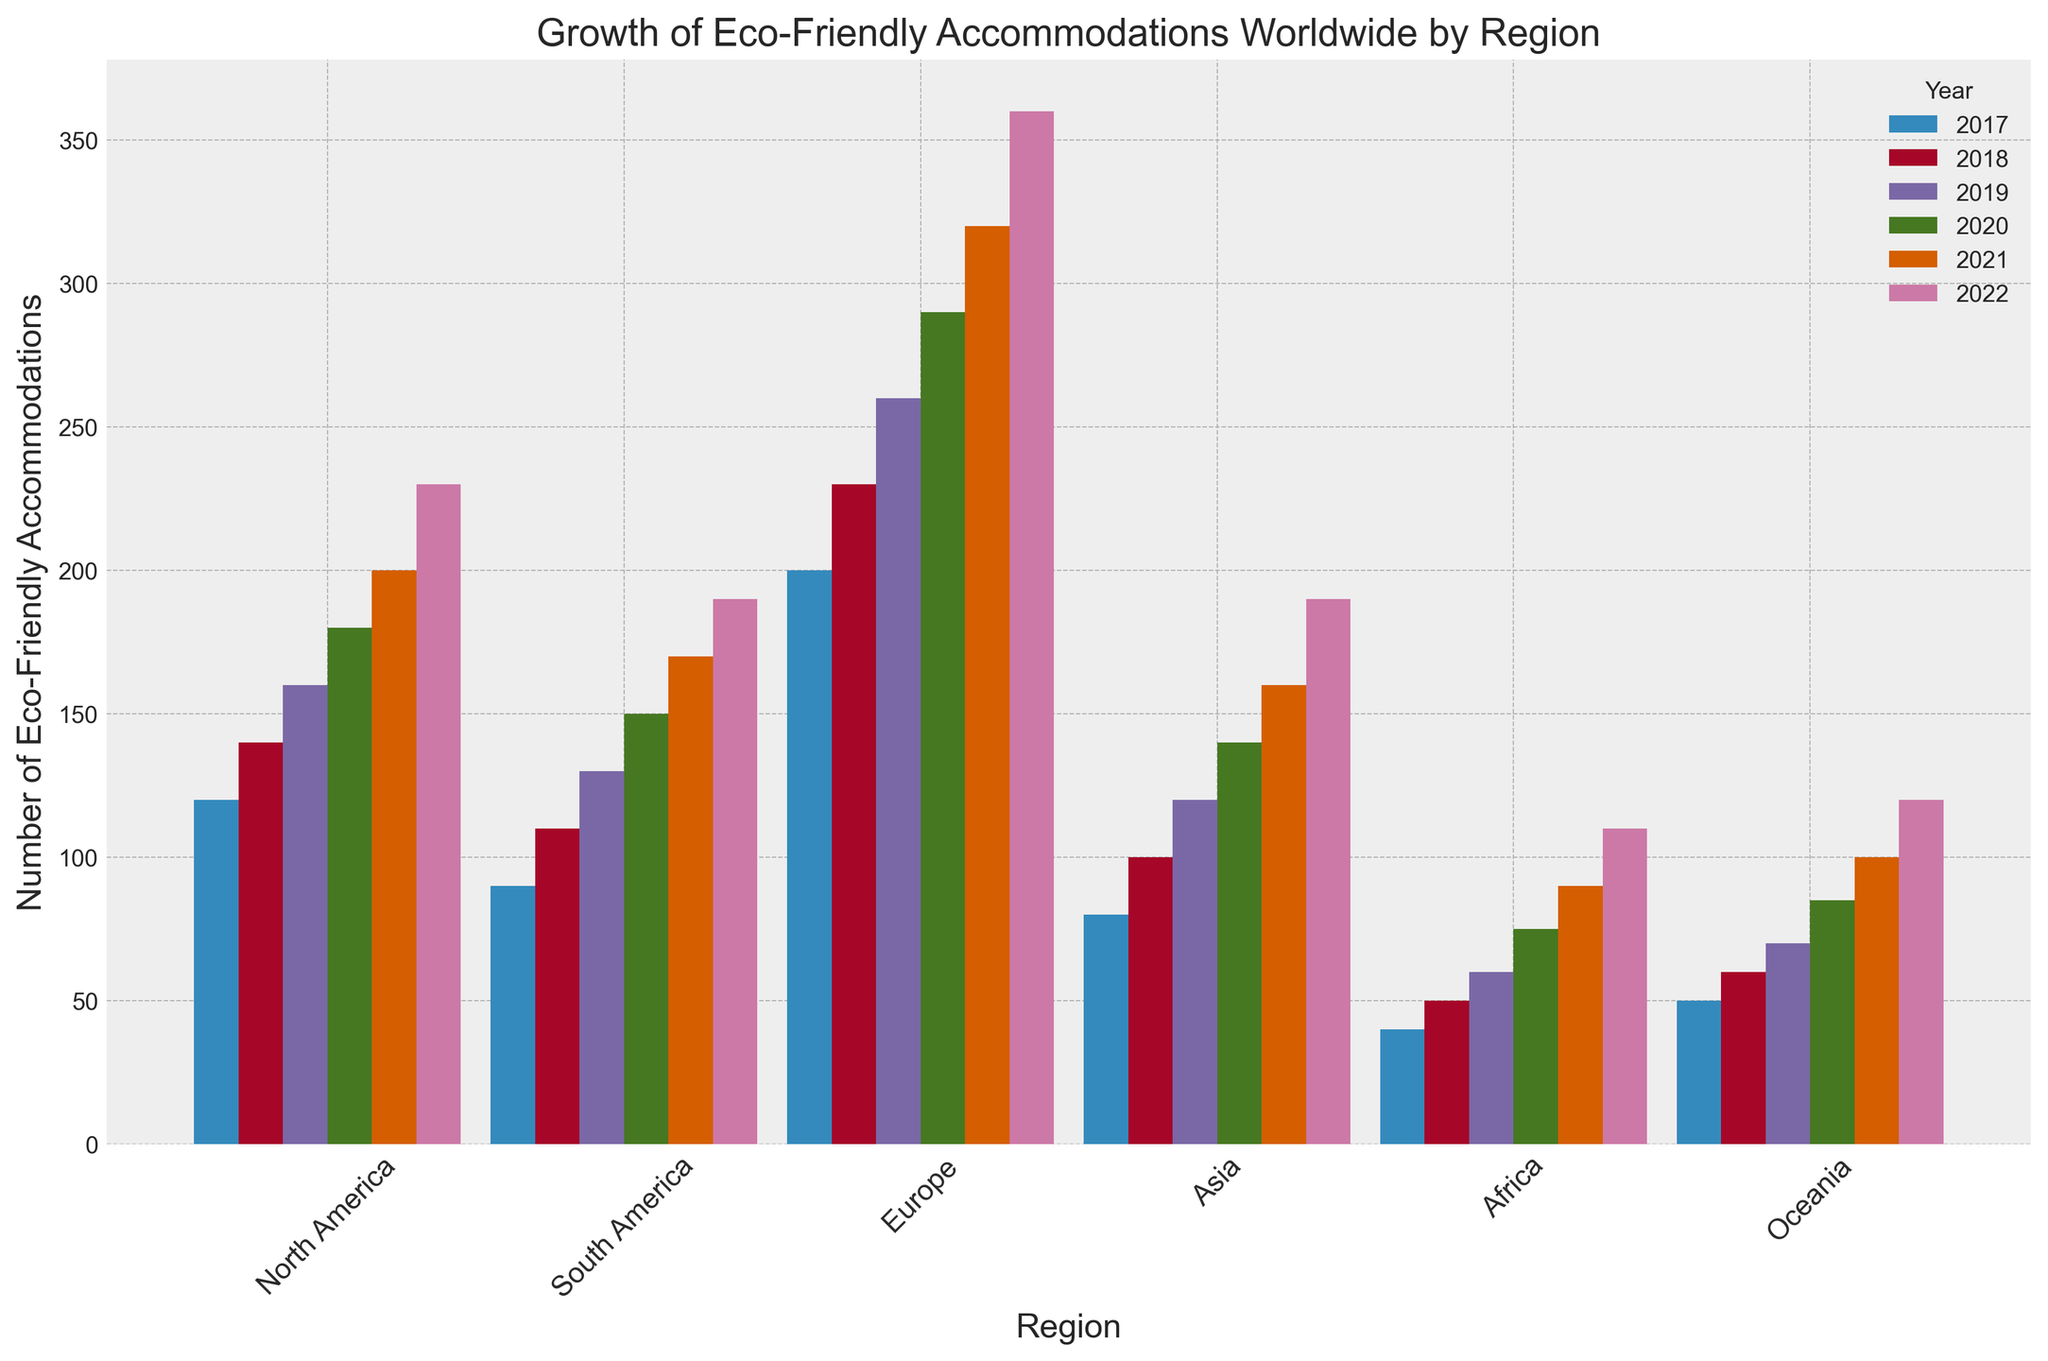What's the region with the most significant increase in the number of eco-friendly accommodations from 2017 to 2022? To find the region with the most significant increase, subtract the 2017 count from the 2022 count for each region. The results are: North America (230-120=110), South America (190-90=100), Europe (360-200=160), Asia (190-80=110), Africa (110-40=70), Oceania (120-50=70). Europe has the largest increase (160).
Answer: Europe Which region consistently had the lowest number of eco-friendly accommodations each year? By visually comparing the bar heights for all regions across each year, Africa consistently has the shortest bars, indicating the lowest number of eco-friendly accommodations each year.
Answer: Africa In which year did North America and South America have the same number of eco-friendly accommodations? By comparing the bar heights for North America and South America, they have the same height in no year based on the provided data; thus, they never had the same number of eco-friendly accommodations in any of the listed years.
Answer: None What was the total number of eco-friendly accommodations in Europe for all the years combined? Add the number of eco-friendly accommodations in Europe for each year: 200 (2017) + 230 (2018) + 260 (2019) + 290 (2020) + 320 (2021) + 360 (2022). The sum is 1660.
Answer: 1660 Which region saw the smallest growth in eco-friendly accommodations from 2017 to 2022? To find the region with the smallest growth, subtract the 2017 count from the 2022 count for each region. North America (230-120=110), South America (190-90=100), Europe (360-200=160), Asia (190-80=110), Africa (110-40=70), Oceania (120-50=70). Both Africa and Oceania have the smallest increase (70).
Answer: Africa and Oceania How does the average number of eco-friendly accommodations in Asia from 2017 to 2022 compare with North America? Calculate the average by adding the annual numbers for each region and dividing by the number of years. Asia: (80 + 100 + 120 + 140 + 160 + 190) / 6 = 790 / 6 ≈ 131.67. North America: (120 + 140 + 160 + 180 + 200 + 230) / 6 = 1030 / 6 ≈ 171.67. North America's average is higher.
Answer: Higher (North America) In 2021, which region had the closest number of eco-friendly accommodations to the overall average for that year? First, find the overall average number of eco-friendly accommodations for 2021 by summing all the regions and dividing by the number of regions: (200 + 170 + 320 + 160 + 90 + 100) / 6 = 1040 / 6 ≈ 173.33. North America (200), South America (170), Europe (320), Asia (160), Africa (90), Oceania (100). South America's 170 is the closest to 173.33.
Answer: South America 